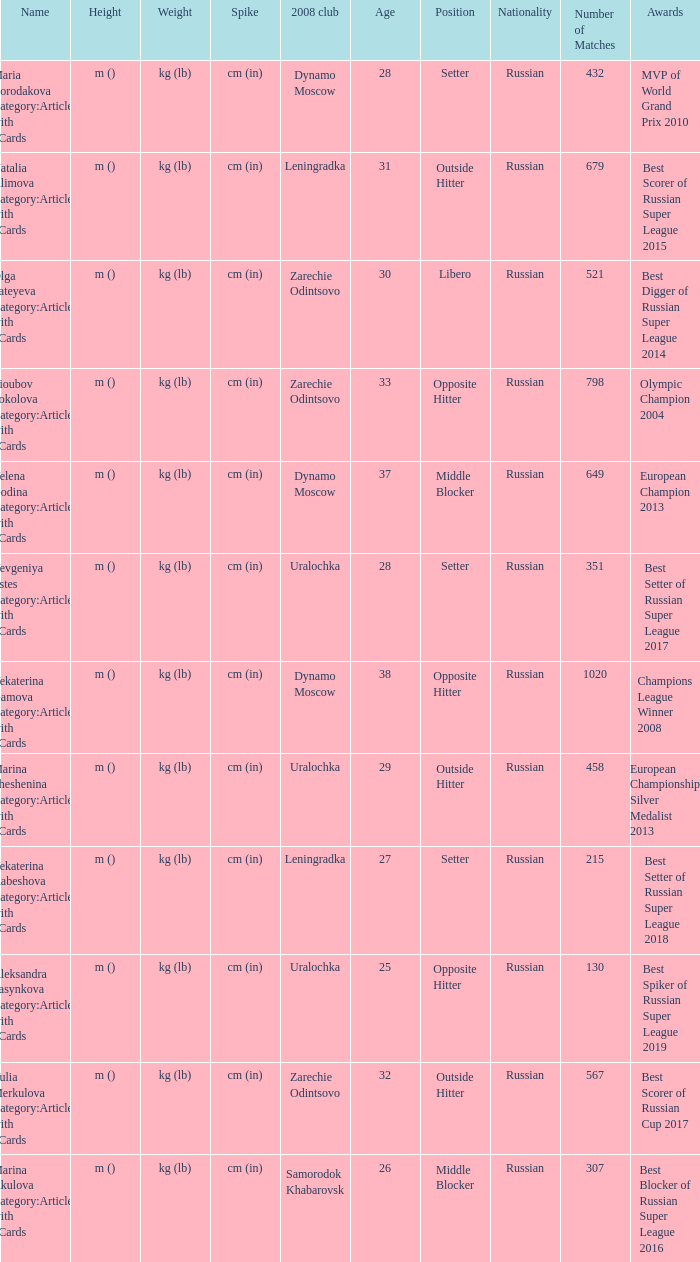What is the name when the 2008 club is uralochka? Yevgeniya Estes Category:Articles with hCards, Marina Sheshenina Category:Articles with hCards, Aleksandra Pasynkova Category:Articles with hCards. 